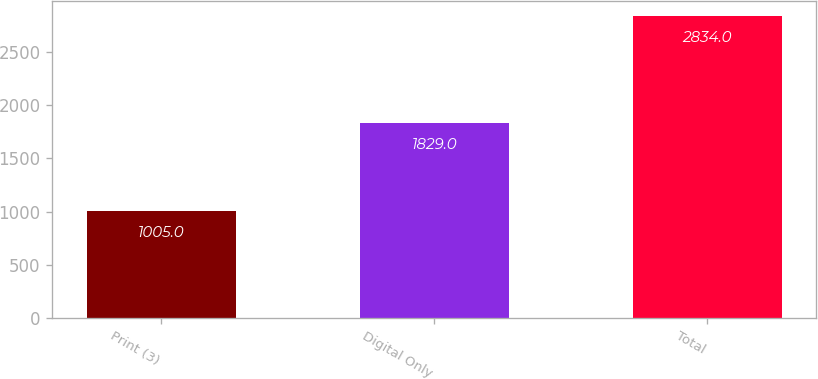<chart> <loc_0><loc_0><loc_500><loc_500><bar_chart><fcel>Print (3)<fcel>Digital Only<fcel>Total<nl><fcel>1005<fcel>1829<fcel>2834<nl></chart> 